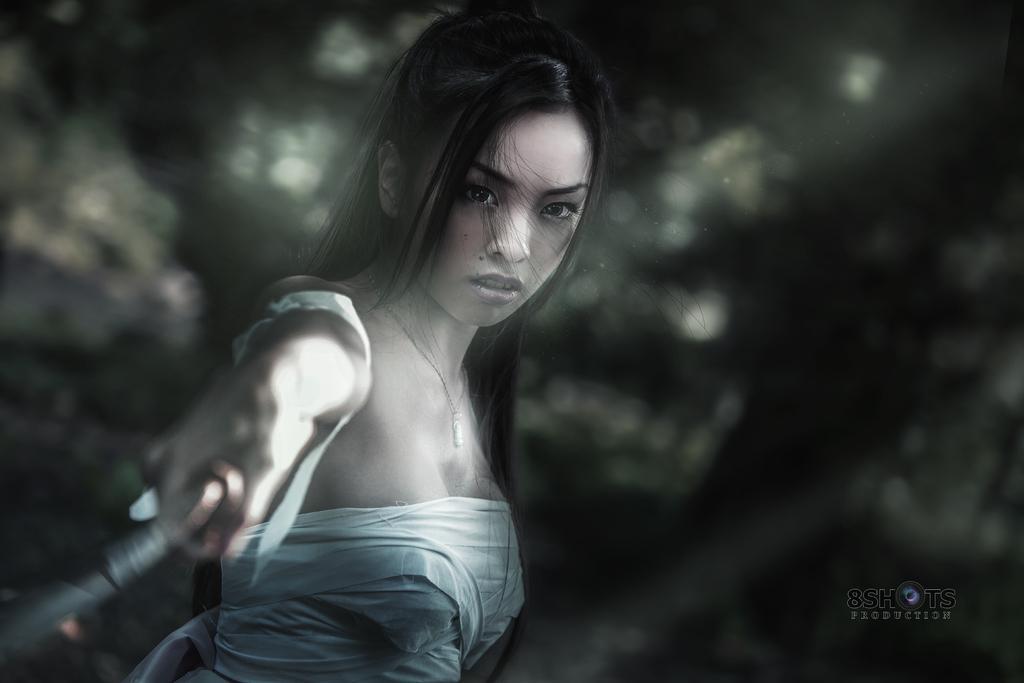Describe this image in one or two sentences. In the center of the image, we can see a lady holding an object and the background is blurry and at the bottom, we can see some text. 